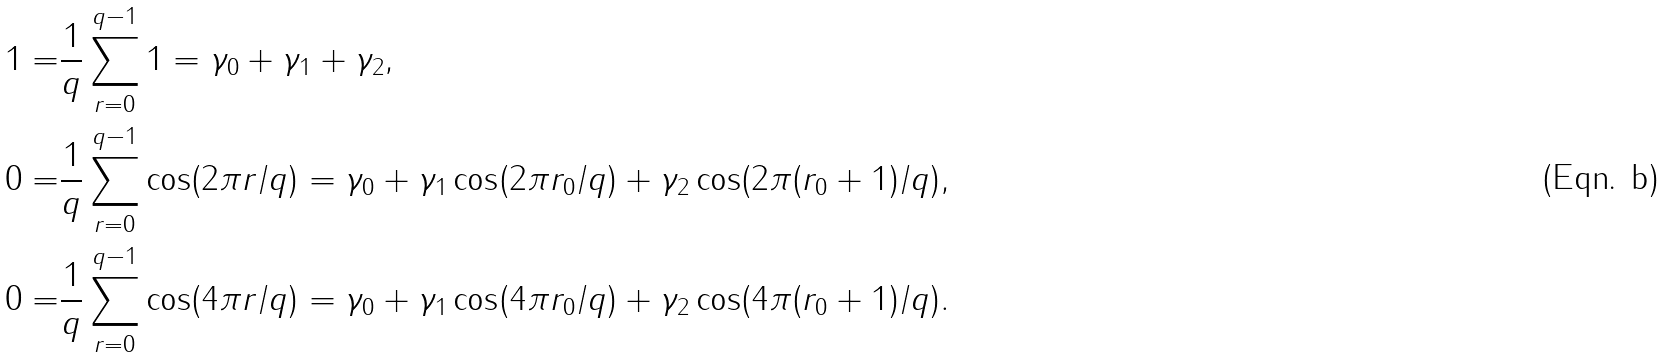<formula> <loc_0><loc_0><loc_500><loc_500>1 = & \frac { 1 } { q } \sum _ { r = 0 } ^ { q - 1 } 1 = \gamma _ { 0 } + \gamma _ { 1 } + \gamma _ { 2 } , \\ 0 = & \frac { 1 } { q } \sum _ { r = 0 } ^ { q - 1 } \cos ( 2 \pi r / q ) = \gamma _ { 0 } + \gamma _ { 1 } \cos ( 2 \pi r _ { 0 } / q ) + \gamma _ { 2 } \cos ( 2 \pi ( r _ { 0 } + 1 ) / q ) , \\ 0 = & \frac { 1 } { q } \sum _ { r = 0 } ^ { q - 1 } \cos ( 4 \pi r / q ) = \gamma _ { 0 } + \gamma _ { 1 } \cos ( 4 \pi r _ { 0 } / q ) + \gamma _ { 2 } \cos ( 4 \pi ( r _ { 0 } + 1 ) / q ) .</formula> 